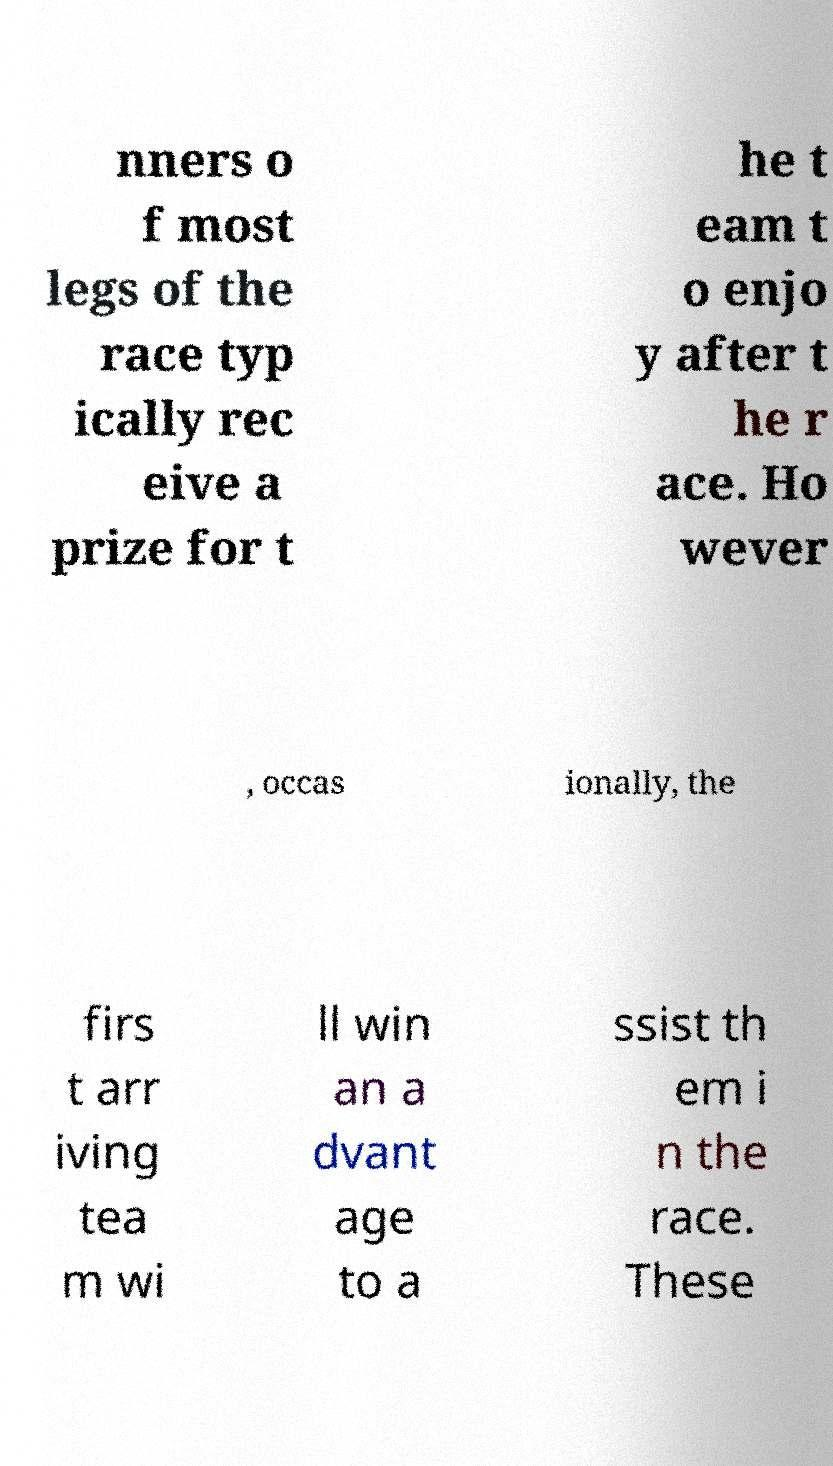Can you read and provide the text displayed in the image?This photo seems to have some interesting text. Can you extract and type it out for me? nners o f most legs of the race typ ically rec eive a prize for t he t eam t o enjo y after t he r ace. Ho wever , occas ionally, the firs t arr iving tea m wi ll win an a dvant age to a ssist th em i n the race. These 